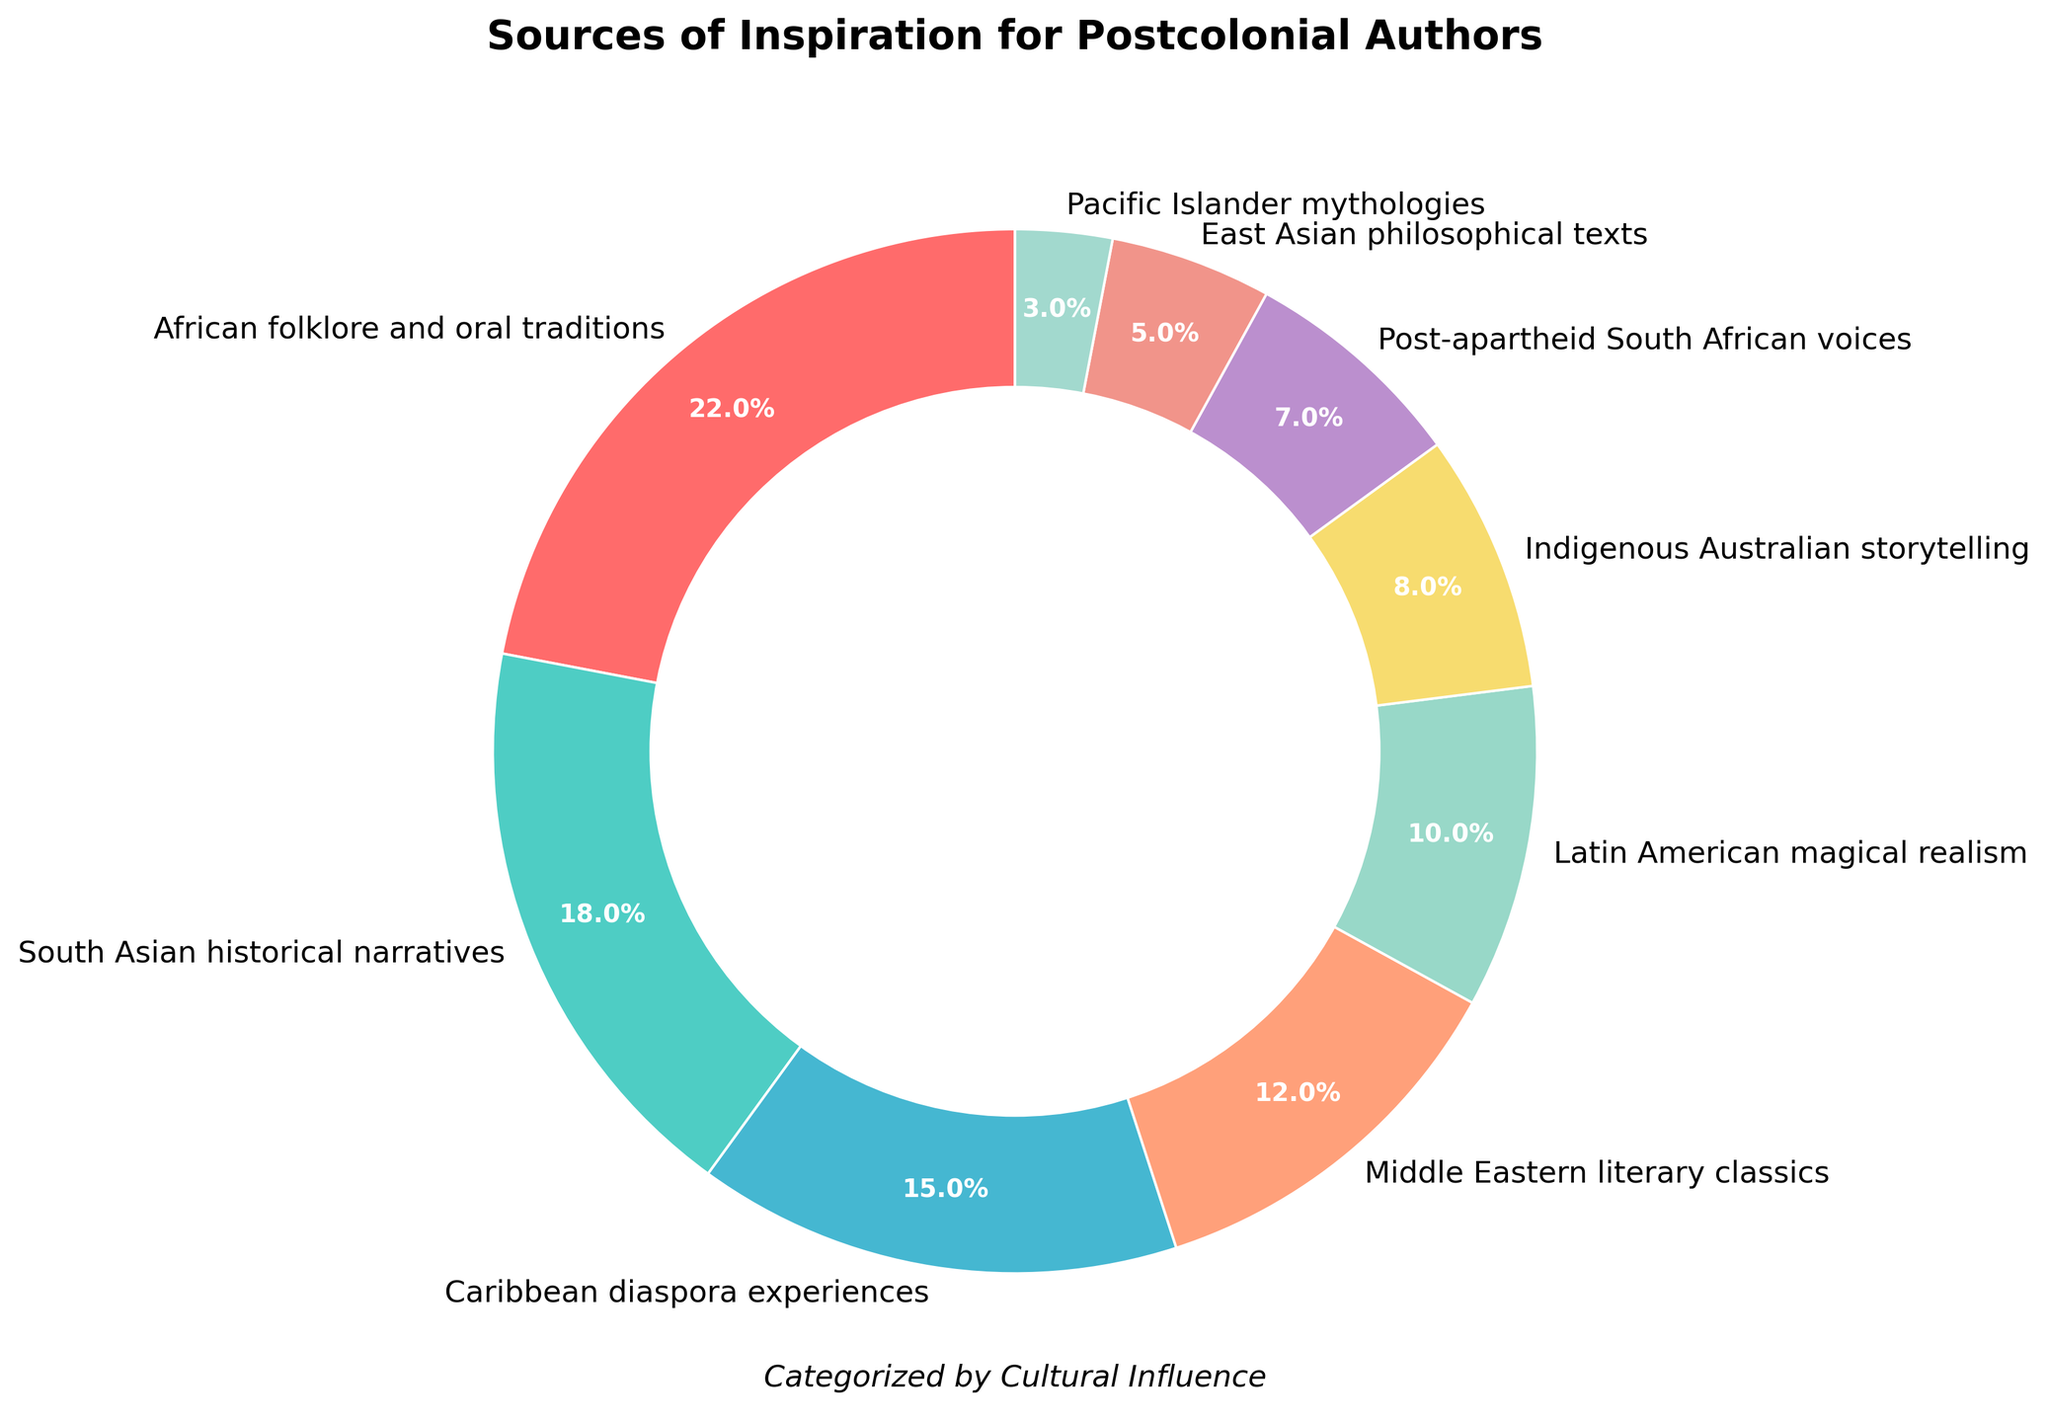Which cultural influence has the highest percentage? Find the largest percentage value in the figure, which is 22%. The corresponding cultural influence is African folklore and oral traditions.
Answer: African folklore and oral traditions What is the combined percentage of Middle Eastern literary classics and Latin American magical realism? Sum the percentages of Middle Eastern literary classics (12%) and Latin American magical realism (10%). 12% + 10% = 22%
Answer: 22% Is African folklore and oral traditions more influential than South Asian historical narratives? Compare the percentages of African folklore and oral traditions (22%) with South Asian historical narratives (18%). African folklore and oral traditions have a higher percentage.
Answer: Yes How do the percentages of Caribbean diaspora experiences and Pacific Islander mythologies compare? Compare 15% for Caribbean diaspora experiences and 3% for Pacific Islander mythologies. 15% is greater than 3%.
Answer: Caribbean diaspora experiences is greater Which cultural influence is represented by the green slice in the chart? Look at the color key in the chart and find the green slice, which corresponds to South Asian historical narratives.
Answer: South Asian historical narratives Which two cultural influences have a combined total of more than 30%? Combine different pairs of percentages until finding one that totals more than 30%. African folklore and oral traditions (22%) and South Asian historical narratives (18%) sum to 40%.
Answer: African folklore and oral traditions, South Asian historical narratives What is the least represented cultural influence in the chart? Identify the smallest percentage, which is 3%. The corresponding cultural influence is Pacific Islander mythologies.
Answer: Pacific Islander mythologies How much higher is the percentage of African folklore and oral traditions compared to Post-apartheid South African voices? Subtract the percentage of Post-apartheid South African voices (7%) from African folklore and oral traditions (22%). 22% - 7% = 15%
Answer: 15% What is the percentage difference between Indigenous Australian storytelling and East Asian philosophical texts? Subtract the percentage of East Asian philosophical texts (5%) from Indigenous Australian storytelling (8%). 8% - 5% = 3%
Answer: 3% If you combine the percentages of Post-apartheid South African voices and Indigenous Australian storytelling, does it exceed the percentage of South Asian historical narratives? Sum the percentages of Post-apartheid South African voices (7%) and Indigenous Australian storytelling (8%). The total is 7% + 8% = 15%, which is lower than South Asian historical narratives (18%).
Answer: No 